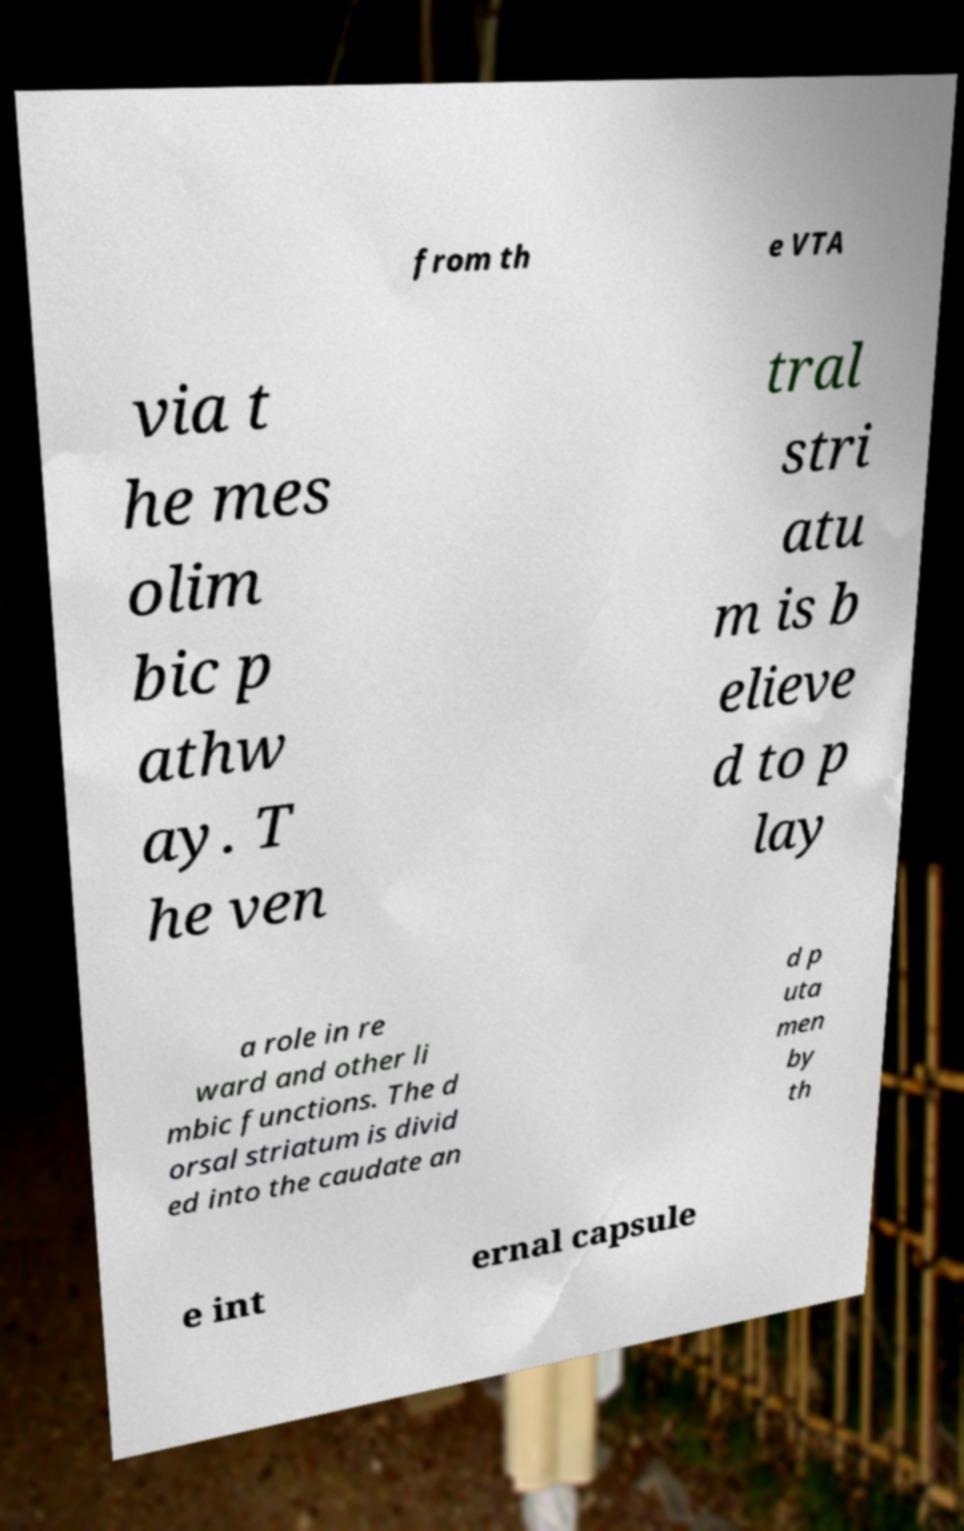Please identify and transcribe the text found in this image. from th e VTA via t he mes olim bic p athw ay. T he ven tral stri atu m is b elieve d to p lay a role in re ward and other li mbic functions. The d orsal striatum is divid ed into the caudate an d p uta men by th e int ernal capsule 